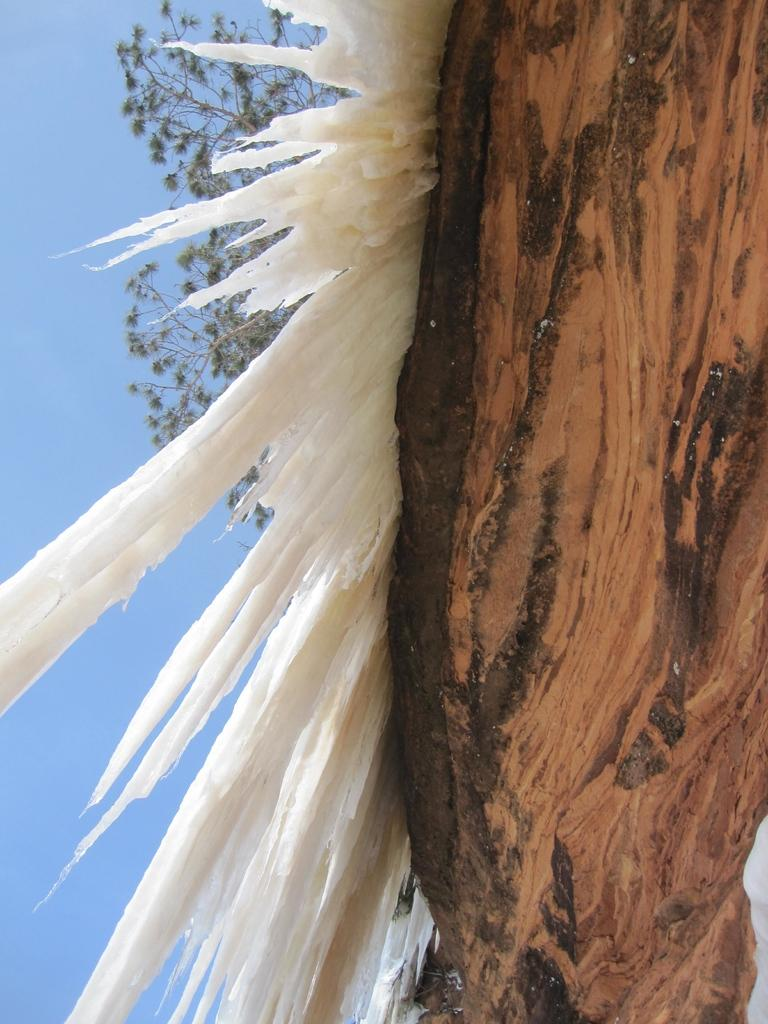What is located at the front of the image? There is a tree in the front of the image. Can you describe the color of any object in the image? There is an object that is white in color in the image. What type of vegetation can be seen in the background of the image? There are leaves visible in the background of the image. What religious beliefs are being practiced in the image? There is no indication of any religious beliefs being practiced in the image. 